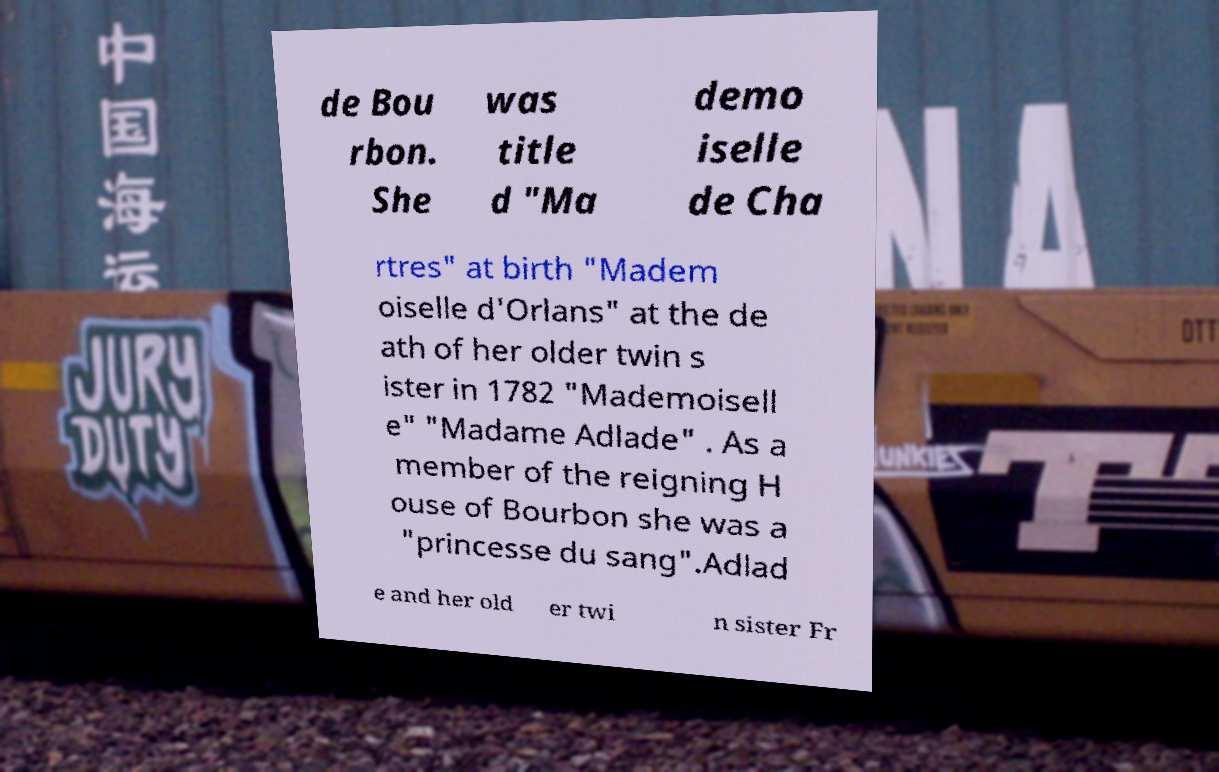I need the written content from this picture converted into text. Can you do that? de Bou rbon. She was title d "Ma demo iselle de Cha rtres" at birth "Madem oiselle d'Orlans" at the de ath of her older twin s ister in 1782 "Mademoisell e" "Madame Adlade" . As a member of the reigning H ouse of Bourbon she was a "princesse du sang".Adlad e and her old er twi n sister Fr 